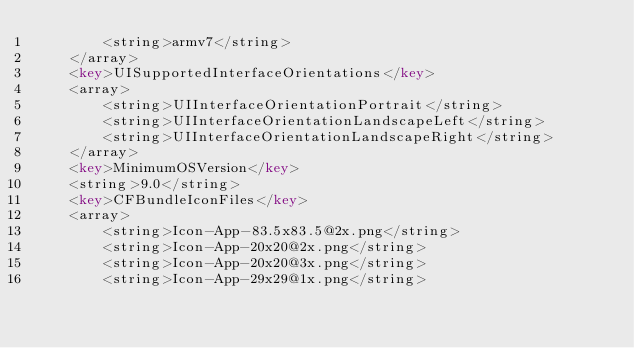Convert code to text. <code><loc_0><loc_0><loc_500><loc_500><_XML_>		<string>armv7</string>
	</array>
	<key>UISupportedInterfaceOrientations</key>
	<array>
		<string>UIInterfaceOrientationPortrait</string>
		<string>UIInterfaceOrientationLandscapeLeft</string>
		<string>UIInterfaceOrientationLandscapeRight</string>
	</array>
	<key>MinimumOSVersion</key>
	<string>9.0</string>
	<key>CFBundleIconFiles</key>
	<array>
		<string>Icon-App-83.5x83.5@2x.png</string>
		<string>Icon-App-20x20@2x.png</string>
		<string>Icon-App-20x20@3x.png</string>
		<string>Icon-App-29x29@1x.png</string></code> 